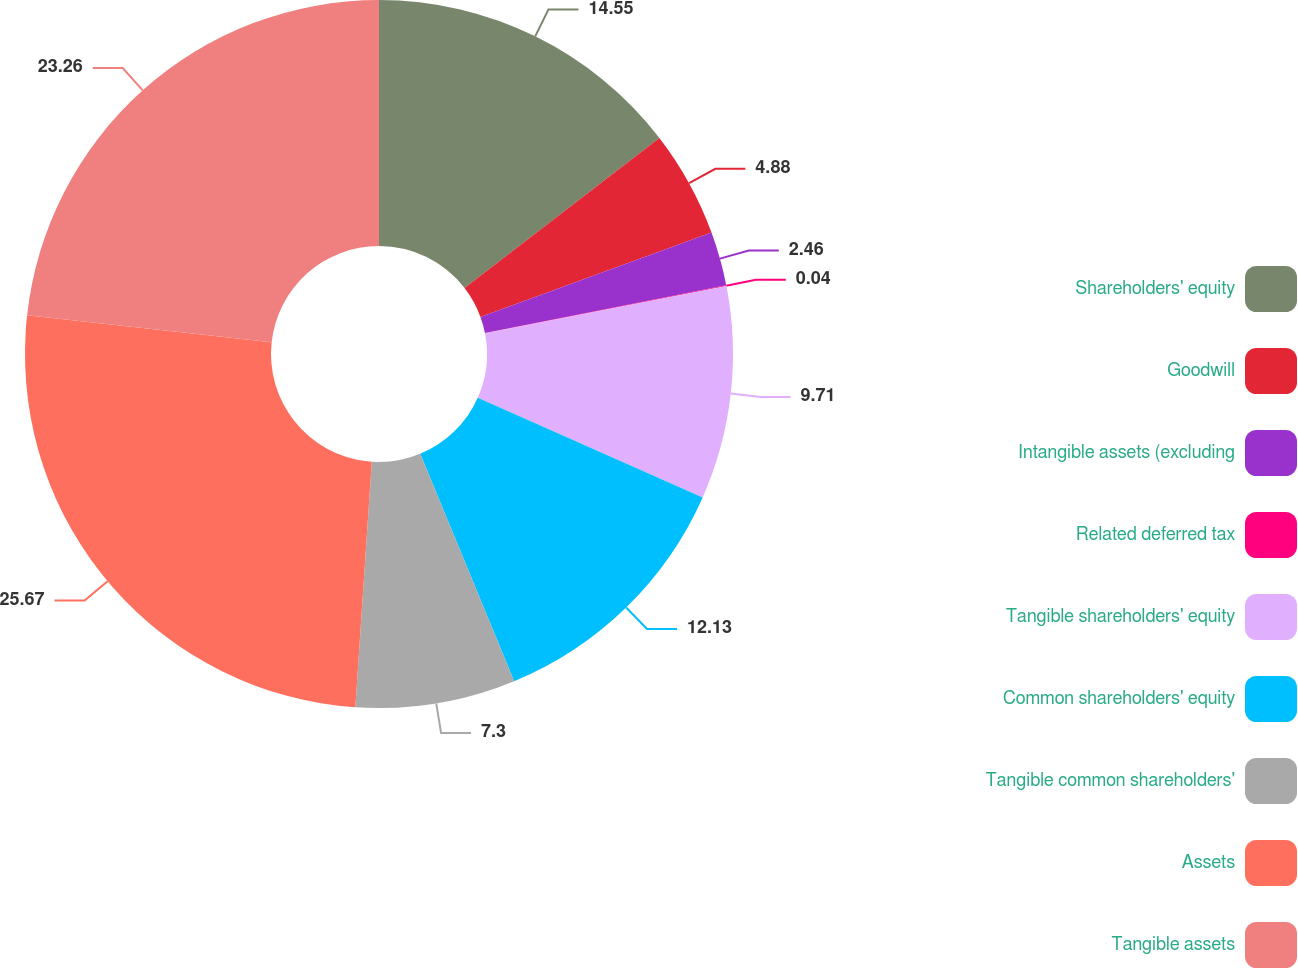Convert chart to OTSL. <chart><loc_0><loc_0><loc_500><loc_500><pie_chart><fcel>Shareholders' equity<fcel>Goodwill<fcel>Intangible assets (excluding<fcel>Related deferred tax<fcel>Tangible shareholders' equity<fcel>Common shareholders' equity<fcel>Tangible common shareholders'<fcel>Assets<fcel>Tangible assets<nl><fcel>14.55%<fcel>4.88%<fcel>2.46%<fcel>0.04%<fcel>9.71%<fcel>12.13%<fcel>7.3%<fcel>25.68%<fcel>23.26%<nl></chart> 